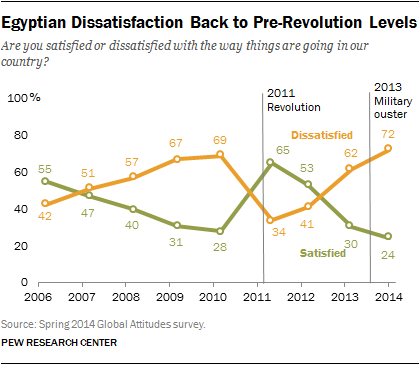Draw attention to some important aspects in this diagram. The rightmost value of the green line is 24. The sum of the median of orange data points from 2010 to 2012 and the largest value of green data points is 122. 